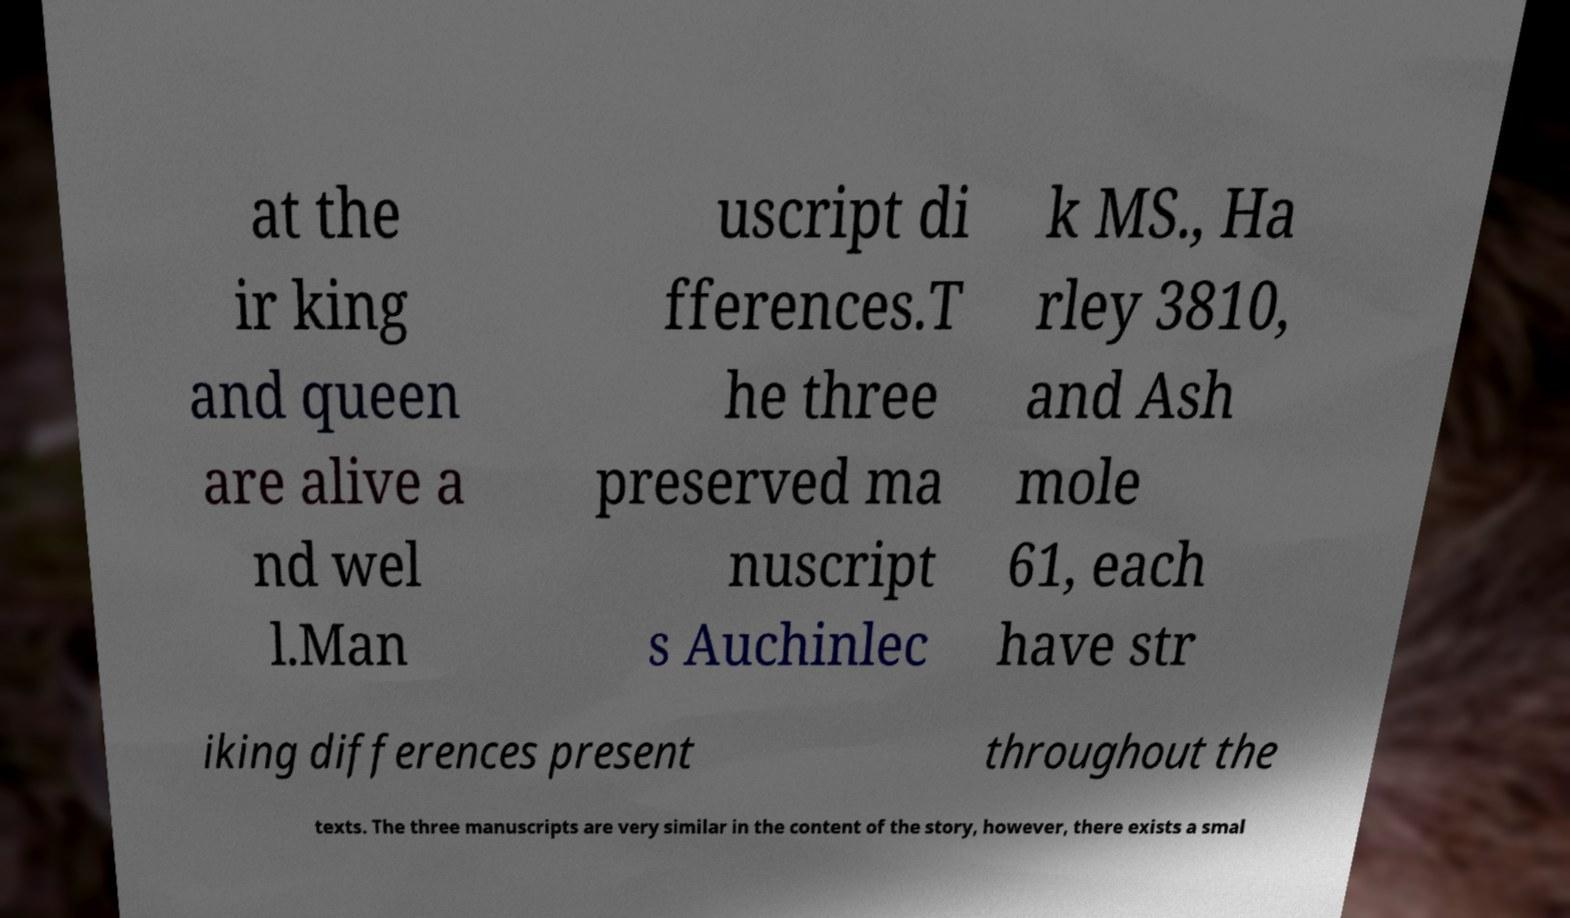Could you extract and type out the text from this image? at the ir king and queen are alive a nd wel l.Man uscript di fferences.T he three preserved ma nuscript s Auchinlec k MS., Ha rley 3810, and Ash mole 61, each have str iking differences present throughout the texts. The three manuscripts are very similar in the content of the story, however, there exists a smal 